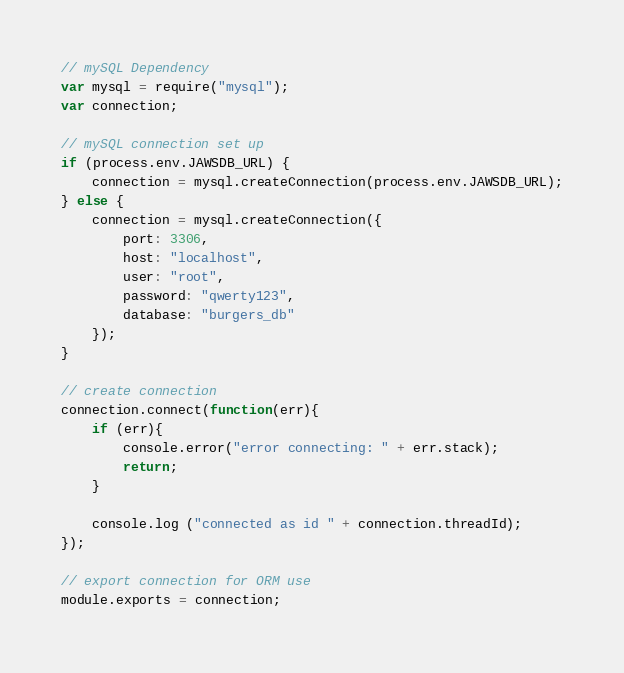Convert code to text. <code><loc_0><loc_0><loc_500><loc_500><_JavaScript_>// mySQL Dependency
var mysql = require("mysql");
var connection;

// mySQL connection set up
if (process.env.JAWSDB_URL) {
    connection = mysql.createConnection(process.env.JAWSDB_URL);
} else {
    connection = mysql.createConnection({
        port: 3306,
        host: "localhost",
        user: "root",
        password: "qwerty123",
        database: "burgers_db"
    });
}

// create connection
connection.connect(function(err){
    if (err){
        console.error("error connecting: " + err.stack);
        return;
    }

    console.log ("connected as id " + connection.threadId);
});

// export connection for ORM use
module.exports = connection;</code> 